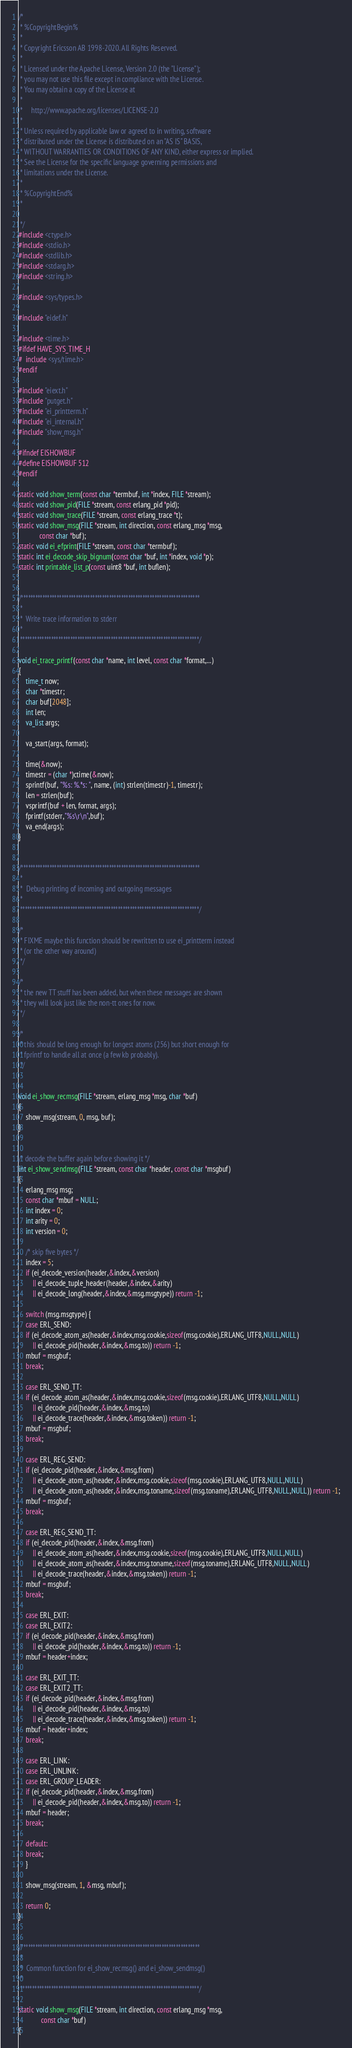Convert code to text. <code><loc_0><loc_0><loc_500><loc_500><_C_>/*
 * %CopyrightBegin%
 *
 * Copyright Ericsson AB 1998-2020. All Rights Reserved.
 *
 * Licensed under the Apache License, Version 2.0 (the "License");
 * you may not use this file except in compliance with the License.
 * You may obtain a copy of the License at
 *
 *     http://www.apache.org/licenses/LICENSE-2.0
 *
 * Unless required by applicable law or agreed to in writing, software
 * distributed under the License is distributed on an "AS IS" BASIS,
 * WITHOUT WARRANTIES OR CONDITIONS OF ANY KIND, either express or implied.
 * See the License for the specific language governing permissions and
 * limitations under the License.
 *
 * %CopyrightEnd%
 *

 */
#include <ctype.h>
#include <stdio.h>
#include <stdlib.h>
#include <stdarg.h>
#include <string.h>

#include <sys/types.h>

#include "eidef.h"

#include <time.h>
#ifdef HAVE_SYS_TIME_H
#  include <sys/time.h>
#endif

#include "eiext.h"
#include "putget.h"
#include "ei_printterm.h"
#include "ei_internal.h"
#include "show_msg.h"

#ifndef EISHOWBUF
#define EISHOWBUF 512
#endif

static void show_term(const char *termbuf, int *index, FILE *stream);
static void show_pid(FILE *stream, const erlang_pid *pid);
static void show_trace(FILE *stream, const erlang_trace *t);
static void show_msg(FILE *stream, int direction, const erlang_msg *msg,
		    const char *buf);
static void ei_efprint(FILE *stream, const char *termbuf);
static int ei_decode_skip_bignum(const char *buf, int *index, void *p);
static int printable_list_p(const uint8 *buf, int buflen);


/***************************************************************************
 *
 *  Write trace information to stderr
 *
 ***************************************************************************/

void ei_trace_printf(const char *name, int level, const char *format,...)
{
    time_t now;
    char *timestr;
    char buf[2048];
    int len;
    va_list args;

    va_start(args, format);

    time(&now);
    timestr = (char *)ctime(&now);
    sprintf(buf, "%s: %.*s: ", name, (int) strlen(timestr)-1, timestr);
    len = strlen(buf);
    vsprintf(buf + len, format, args);
    fprintf(stderr,"%s\r\n",buf);
    va_end(args);
}


/***************************************************************************
 *
 *  Debug printing of incoming and outgoing messages
 *
 ***************************************************************************/

/*
 * FIXME maybe this function should be rewritten to use ei_printterm instead
 * (or the other way around)
 */

/* 
 * the new TT stuff has been added, but when these messages are shown
 * they will look just like the non-tt ones for now.
 */
   
/*
 * this should be long enough for longest atoms (256) but short enough for
 * fprintf to handle all at once (a few kb probably).
 */


void ei_show_recmsg(FILE *stream, erlang_msg *msg, char *buf)
{
    show_msg(stream, 0, msg, buf);
}


/* decode the buffer again before showing it */
int ei_show_sendmsg(FILE *stream, const char *header, const char *msgbuf)
{
    erlang_msg msg;
    const char *mbuf = NULL;
    int index = 0;
    int arity = 0;
    int version = 0;

    /* skip five bytes */
    index = 5;
    if (ei_decode_version(header,&index,&version)
        || ei_decode_tuple_header(header,&index,&arity)
        || ei_decode_long(header,&index,&msg.msgtype)) return -1;

    switch (msg.msgtype) {
    case ERL_SEND:
	if (ei_decode_atom_as(header,&index,msg.cookie,sizeof(msg.cookie),ERLANG_UTF8,NULL,NULL) 
	    || ei_decode_pid(header,&index,&msg.to)) return -1;
	mbuf = msgbuf;
	break;

    case ERL_SEND_TT:
	if (ei_decode_atom_as(header,&index,msg.cookie,sizeof(msg.cookie),ERLANG_UTF8,NULL,NULL) 
	    || ei_decode_pid(header,&index,&msg.to)
	    || ei_decode_trace(header,&index,&msg.token)) return -1;
	mbuf = msgbuf;
	break;
    
    case ERL_REG_SEND:
	if (ei_decode_pid(header,&index,&msg.from) 
	    || ei_decode_atom_as(header,&index,msg.cookie,sizeof(msg.cookie),ERLANG_UTF8,NULL,NULL) 
	    || ei_decode_atom_as(header,&index,msg.toname,sizeof(msg.toname),ERLANG_UTF8,NULL,NULL)) return -1;
	mbuf = msgbuf;
	break;
    
    case ERL_REG_SEND_TT:
	if (ei_decode_pid(header,&index,&msg.from) 
	    || ei_decode_atom_as(header,&index,msg.cookie,sizeof(msg.cookie),ERLANG_UTF8,NULL,NULL) 
	    || ei_decode_atom_as(header,&index,msg.toname,sizeof(msg.toname),ERLANG_UTF8,NULL,NULL)
	    || ei_decode_trace(header,&index,&msg.token)) return -1;
	mbuf = msgbuf;
	break;

    case ERL_EXIT:
    case ERL_EXIT2:
	if (ei_decode_pid(header,&index,&msg.from) 
	    || ei_decode_pid(header,&index,&msg.to)) return -1;
	mbuf = header+index;

    case ERL_EXIT_TT:
    case ERL_EXIT2_TT:
	if (ei_decode_pid(header,&index,&msg.from) 
	    || ei_decode_pid(header,&index,&msg.to)
	    || ei_decode_trace(header,&index,&msg.token)) return -1;
	mbuf = header+index;
	break;
    
    case ERL_LINK:
    case ERL_UNLINK:
    case ERL_GROUP_LEADER:
	if (ei_decode_pid(header,&index,&msg.from) 
	    || ei_decode_pid(header,&index,&msg.to)) return -1;
	mbuf = header;
	break;
    
    default:
	break;
    }

    show_msg(stream, 1, &msg, mbuf);

    return 0;
}


/***************************************************************************
 *
 *  Common function for ei_show_recmsg() and ei_show_sendmsg()
 *
 ***************************************************************************/

static void show_msg(FILE *stream, int direction, const erlang_msg *msg,
		     const char *buf)
{</code> 